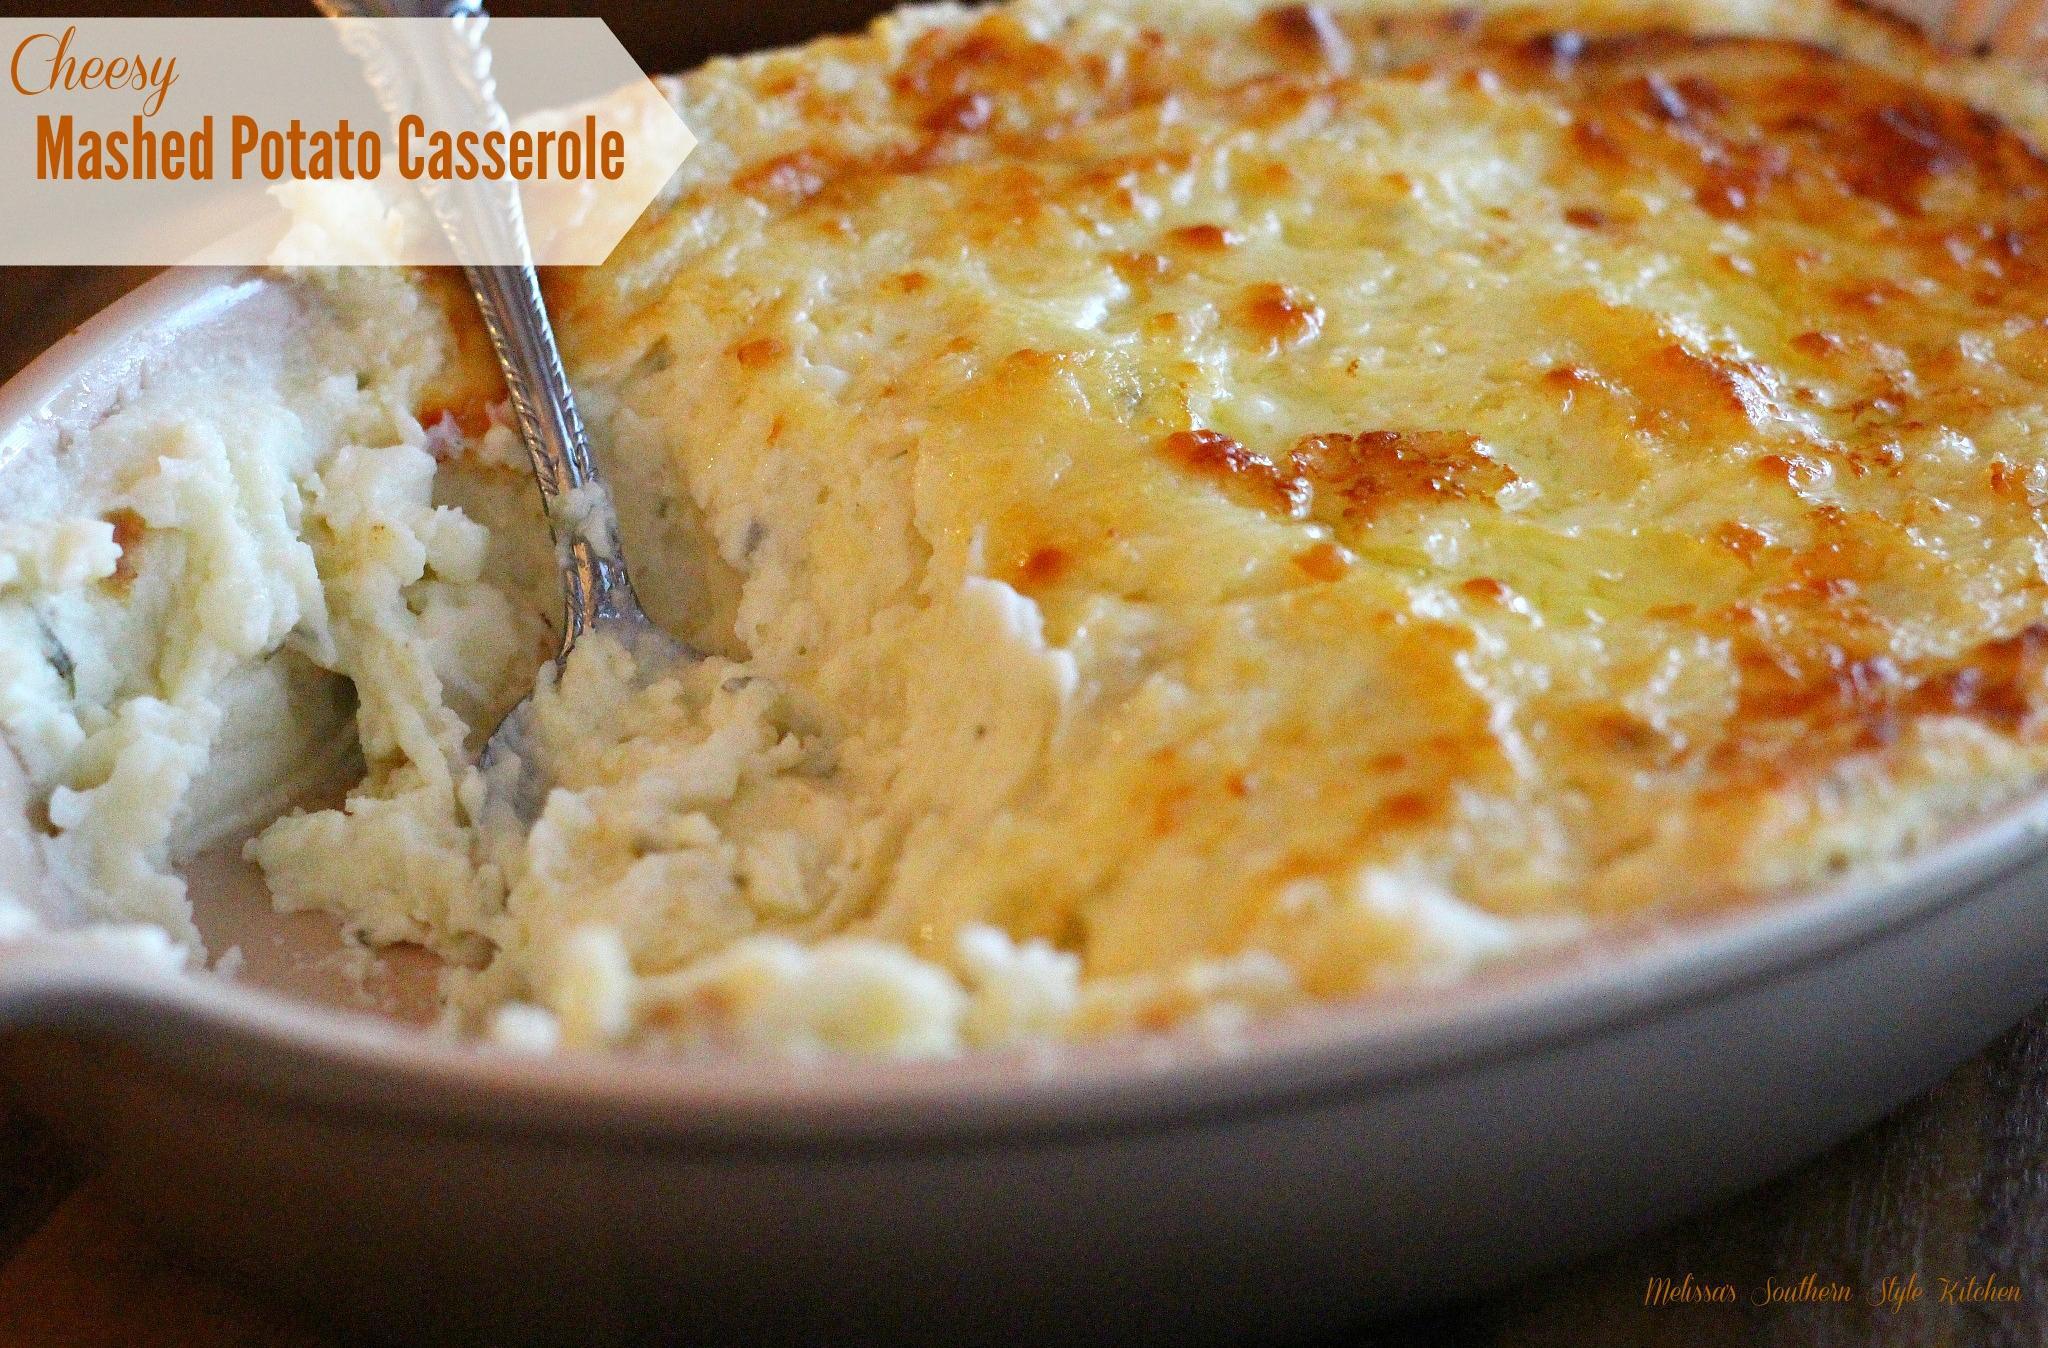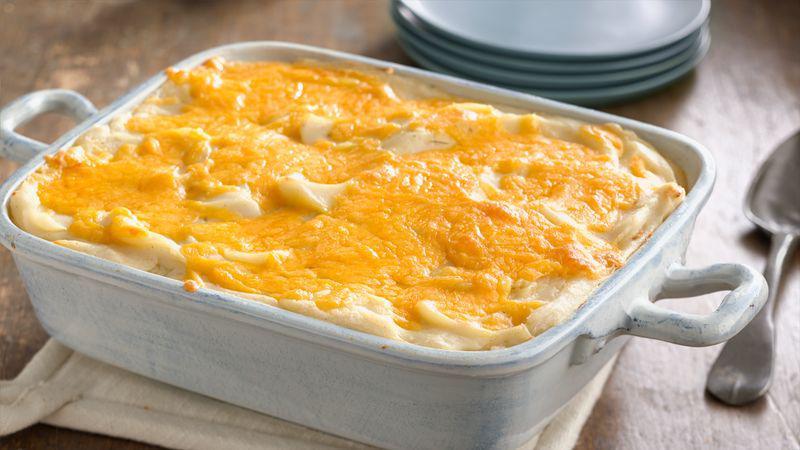The first image is the image on the left, the second image is the image on the right. For the images shown, is this caption "One image shows a cheese topped casserole in a reddish-orange dish with white interior, and the other image shows a casserole in a solid white dish." true? Answer yes or no. No. The first image is the image on the left, the second image is the image on the right. For the images displayed, is the sentence "The food in one of the images is sitting in a red casserole dish." factually correct? Answer yes or no. No. 